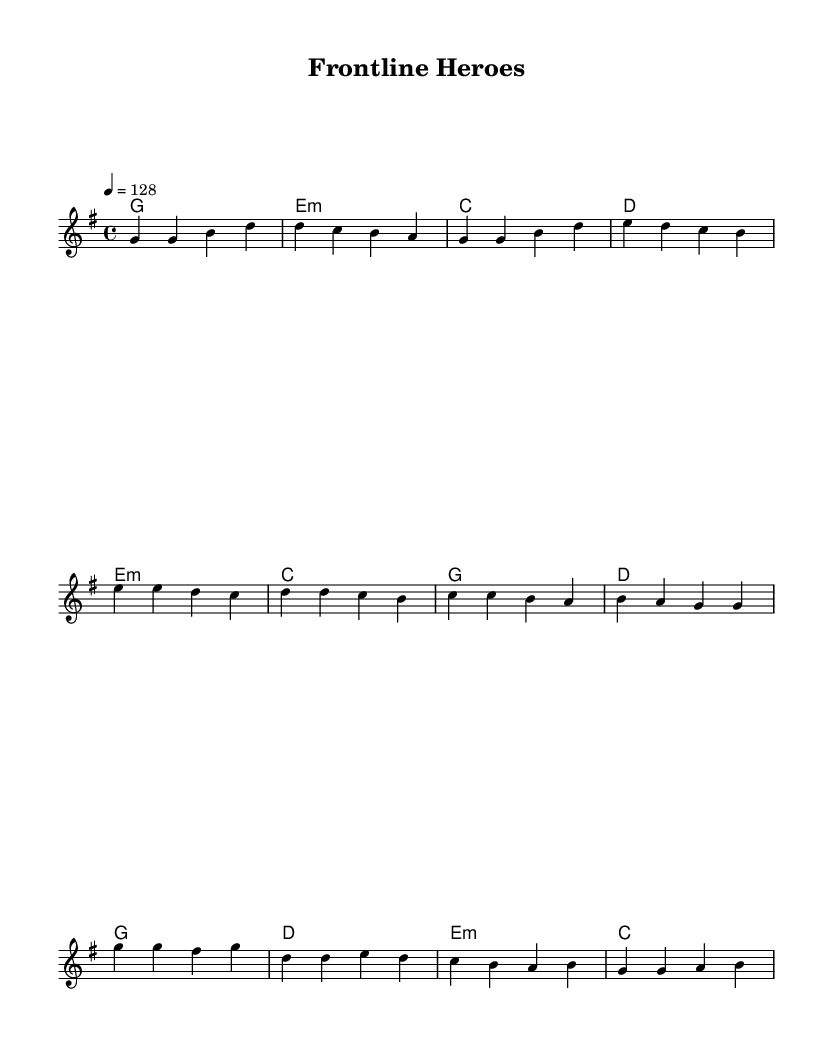What is the key signature of this music? The key signature is G major, which has one sharp (F#). You can identify the key signature by looking at the starting part of the sheet music where it indicates the sharps or flats.
Answer: G major What is the time signature of this piece? The time signature is 4/4, which means there are four beats in each measure and the quarter note gets one beat. You can find the time signature indicated at the beginning of the music right after the key signature.
Answer: 4/4 What is the tempo marking for this piece? The tempo marking is 128 beats per minute (BPM) indicated by the tempo directive. This tells you how fast the piece should be played, and it is specified as '4 = 128', meaning the quarter note gets 128 beats.
Answer: 128 How many measures are in the verse section? The verse section contains 4 measures. You can count the measures by looking at the bar lines that separate each measure in the melody part.
Answer: 4 What is the first chord of the chorus? The first chord of the chorus is G major. You identify it by looking at the chord symbols placed above the melody staff. The first indicated chord for the chorus section is a G major.
Answer: G What type of musical form does this piece primarily use? This piece primarily uses a verse-chorus form, which is typical in K-Pop music. This is identified by the structure where you have repeated sections like the verse followed by the pre-chorus and then the chorus.
Answer: Verse-chorus What is the mood this K-Pop track aims to convey based on its characteristics? The mood aimed at is energetic, which is characteristic of dance tracks. This is derived from its fast tempo, lively melodies, and the theme celebrating healthcare workers, inspiring positivity and appreciation.
Answer: Energetic 